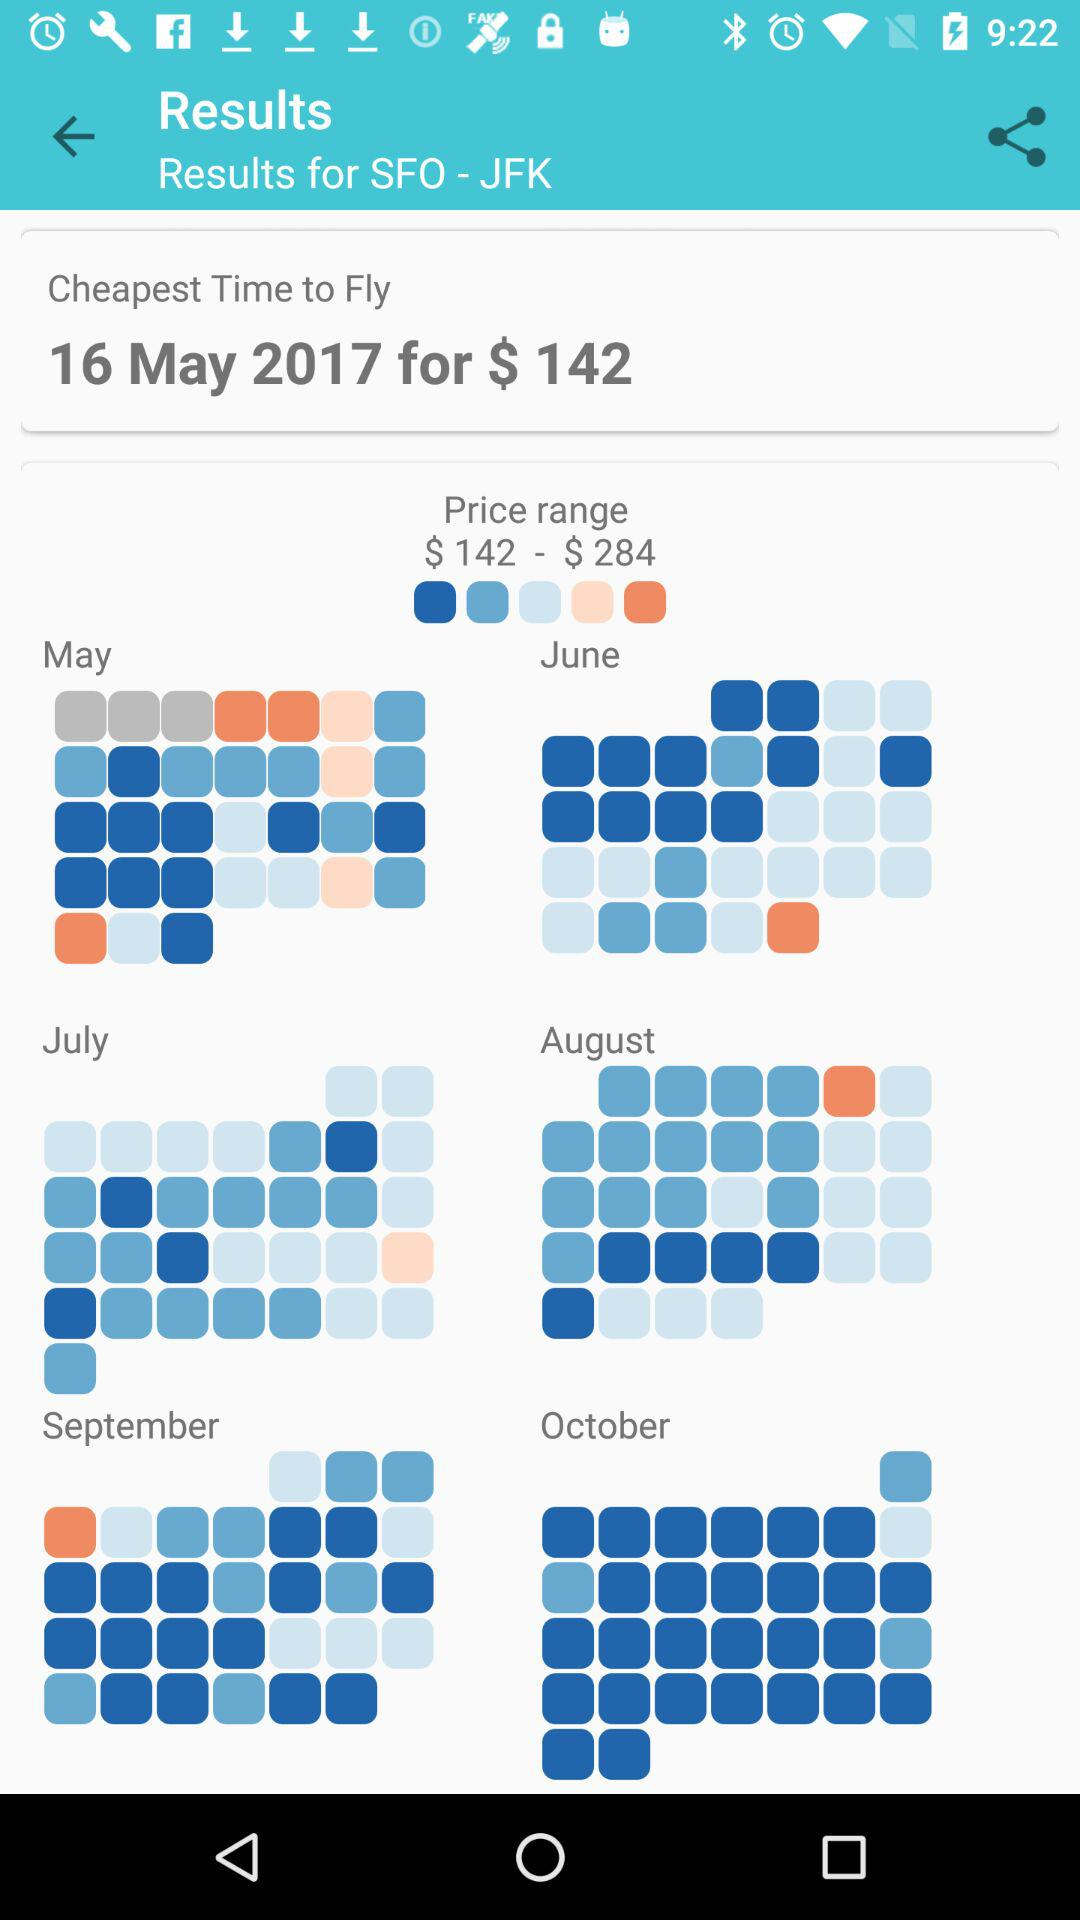What is the cheapest time to fly? The cheapest time to fly is May 16, 2017. 